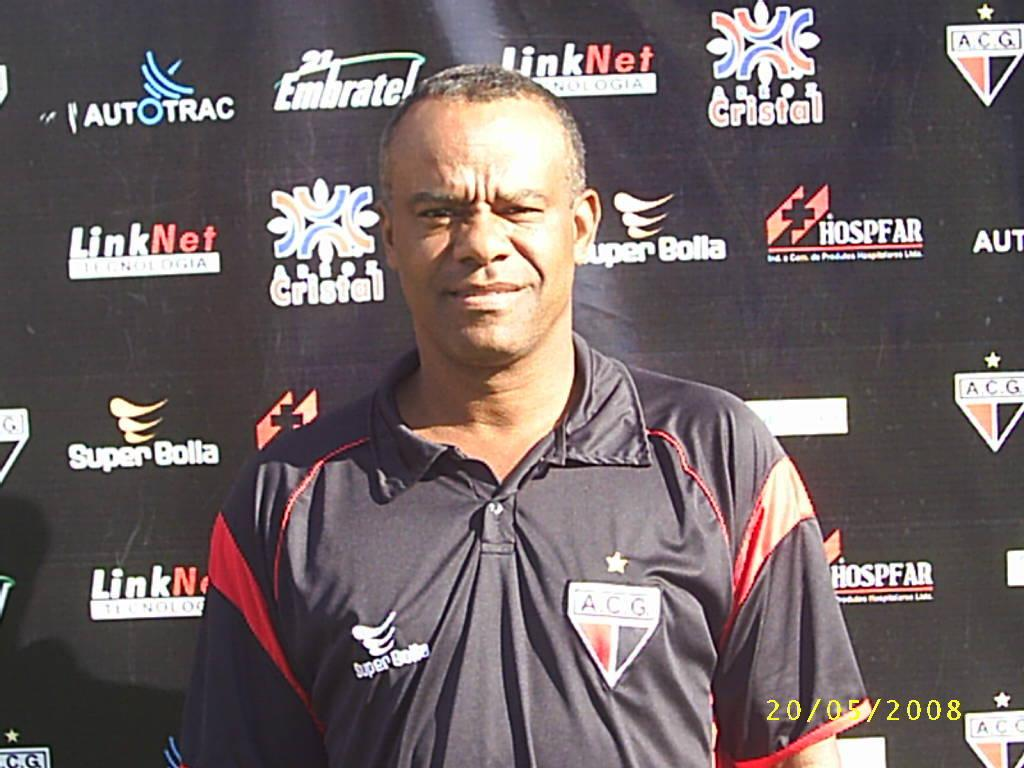<image>
Describe the image concisely. a man in front of an ad that says link 